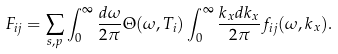<formula> <loc_0><loc_0><loc_500><loc_500>F _ { i j } = \sum _ { s , p } \int _ { 0 } ^ { \infty } \frac { d \omega } { 2 \pi } \Theta ( \omega , T _ { i } ) \int _ { 0 } ^ { \infty } \frac { k _ { x } d k _ { x } } { 2 \pi } f _ { i j } ( \omega , k _ { x } ) .</formula> 